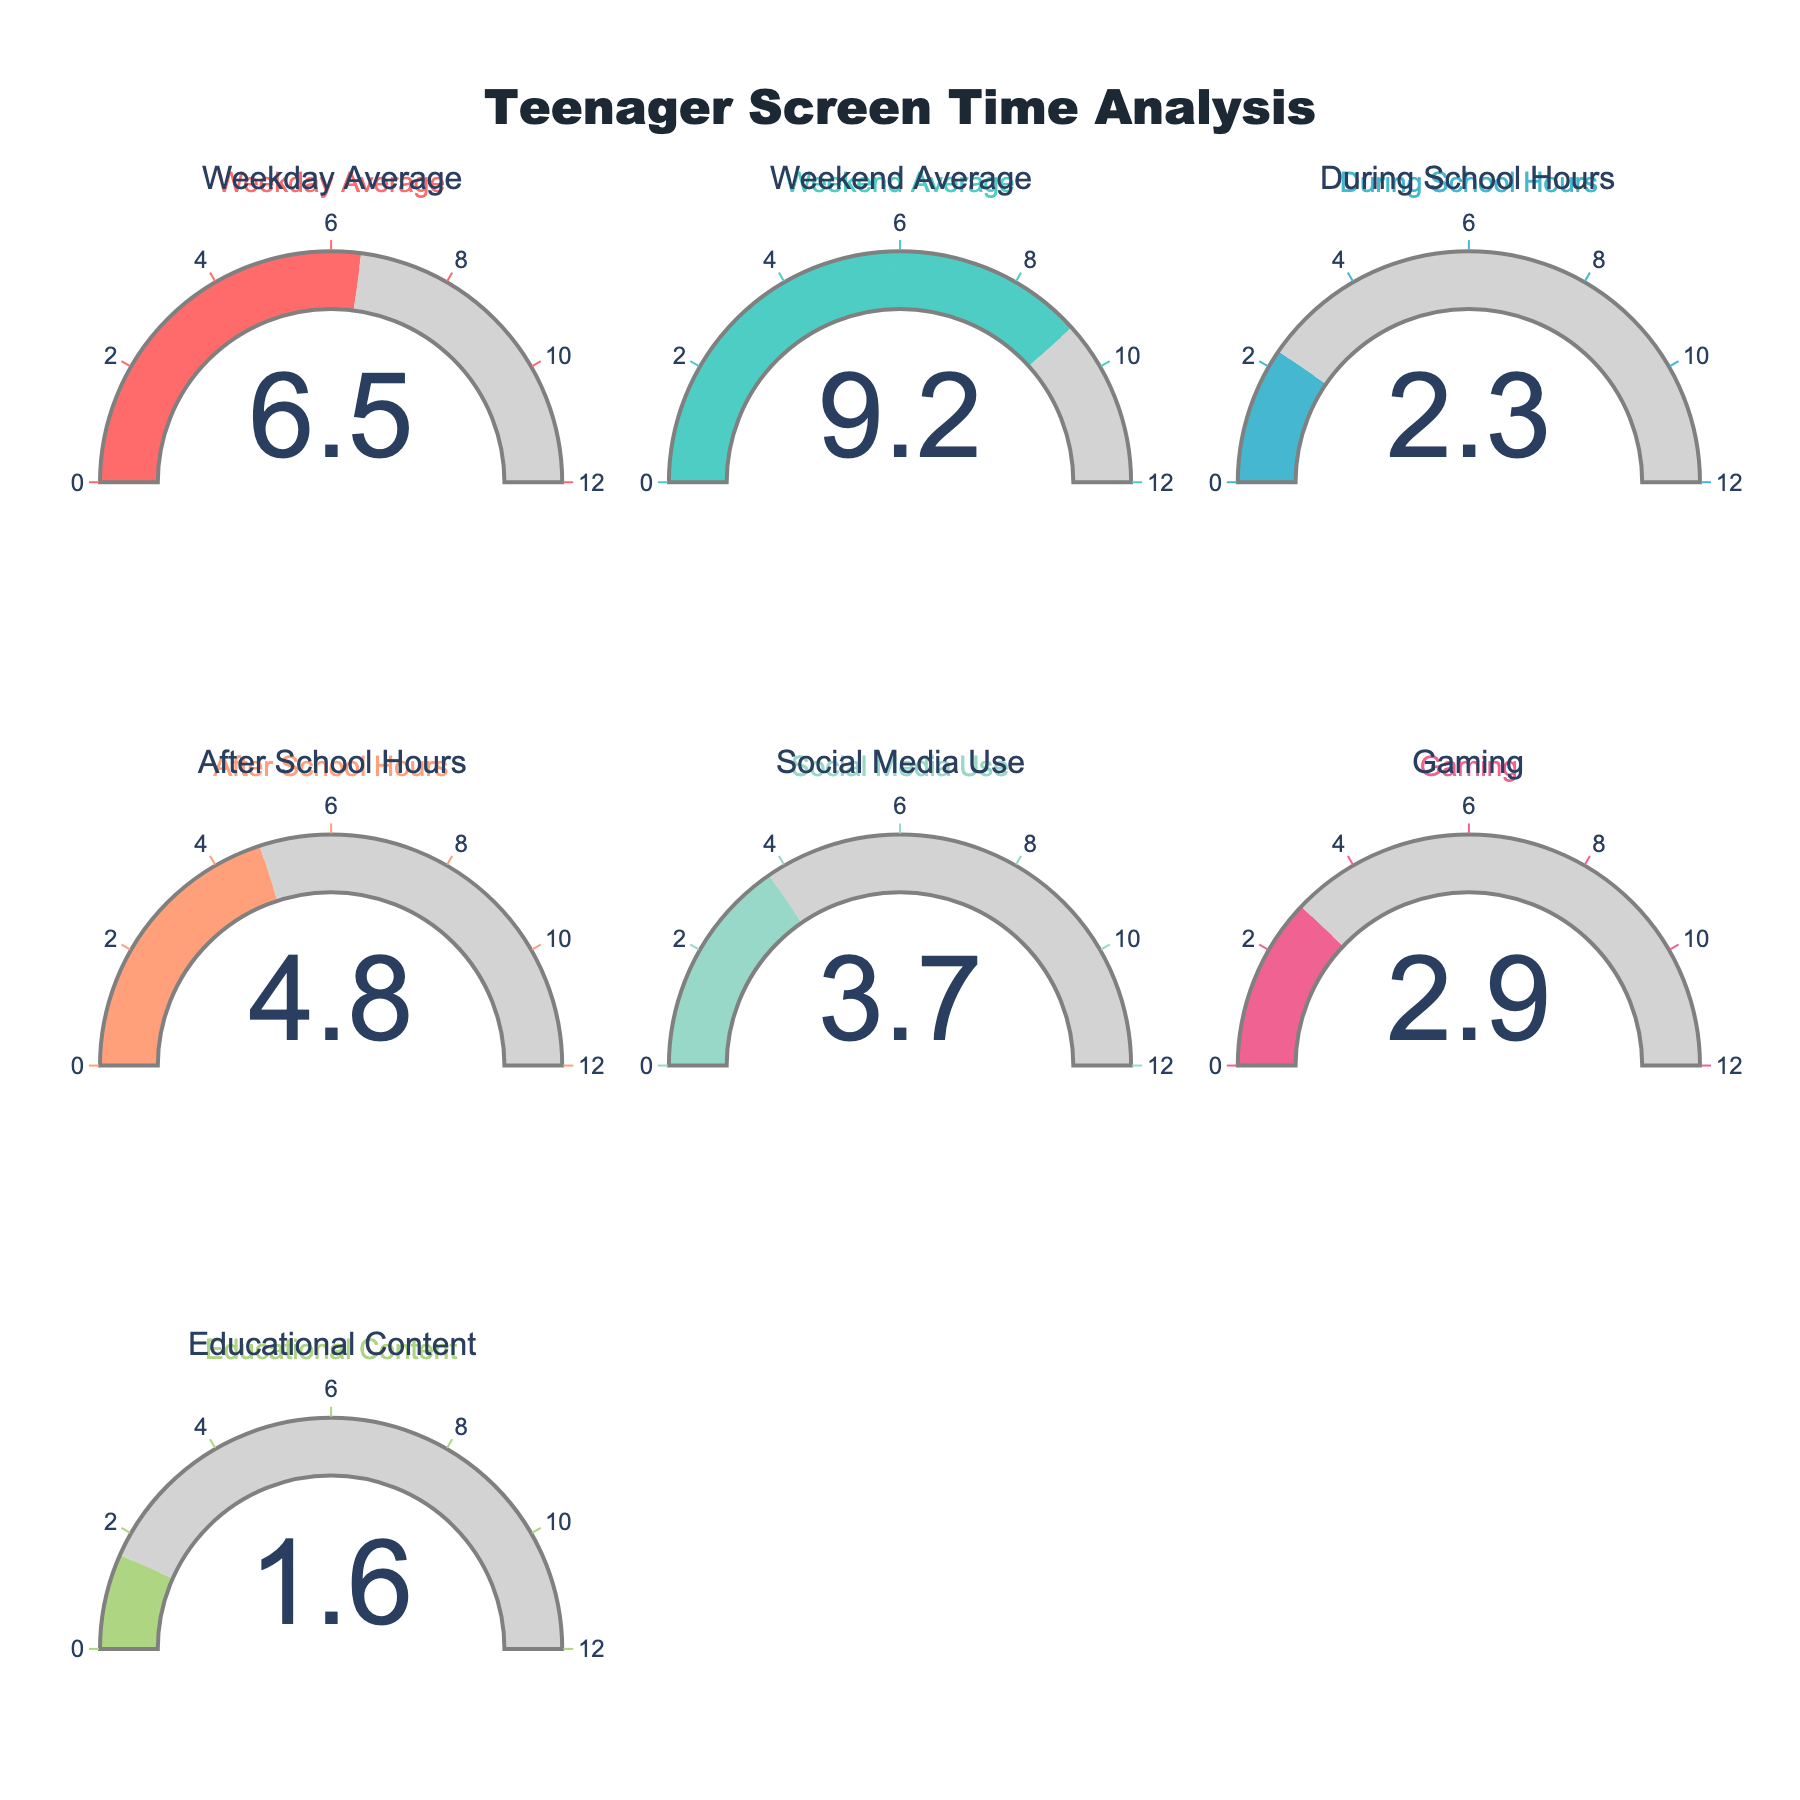What is the average daily screen time for teenagers on weekdays? The gauge chart for "Weekday Average" indicates the average daily screen time in hours for teenagers on weekdays.
Answer: 6.5 Which period has the highest average screen time: weekdays or weekends? Compare the "Weekday Average" gauge with the "Weekend Average" gauge. The "Weekend Average" gauge shows a higher value (9.2 hours) compared to the "Weekday Average" (6.5 hours).
Answer: Weekends What's the total average daily screen time covering both during school and after school hours? Sum the values from the "During School Hours" gauge and the "After School Hours" gauge. The values are 2.3 hours and 4.8 hours respectively, leading to a total of 2.3 + 4.8 = 7.1 hours.
Answer: 7.1 hours How much more time do teenagers spend on social media compared to educational content daily? Determine the difference between the "Social Media Use" gauge (3.7 hours) and the "Educational Content" gauge (1.6 hours). 3.7 - 1.6 = 2.1 hours.
Answer: 2.1 hours Which activity has the least amount of average screen time? Identify the lowest value among all gauges. The "Educational Content" gauge shows the smallest value at 1.6 hours.
Answer: Educational Content How does the average daily gaming time compare to the weekday average screen time? Compare the values of the "Gaming" gauge (2.9 hours) and the "Weekday Average" gauge (6.5 hours). The weekday average is higher.
Answer: Weekday average is higher What is the combined average screen time for social media use and gaming? Add the values from the "Social Media Use" gauge (3.7 hours) and the "Gaming" gauge (2.9 hours). The combined average is 3.7 + 2.9 = 6.6 hours.
Answer: 6.6 hours Which category has a value closest to 5 hours of screen time? Identify the gauge with a value nearest to 5 hours. "After School Hours" shows 4.8 hours, which is closest to 5 hours.
Answer: After School Hours 